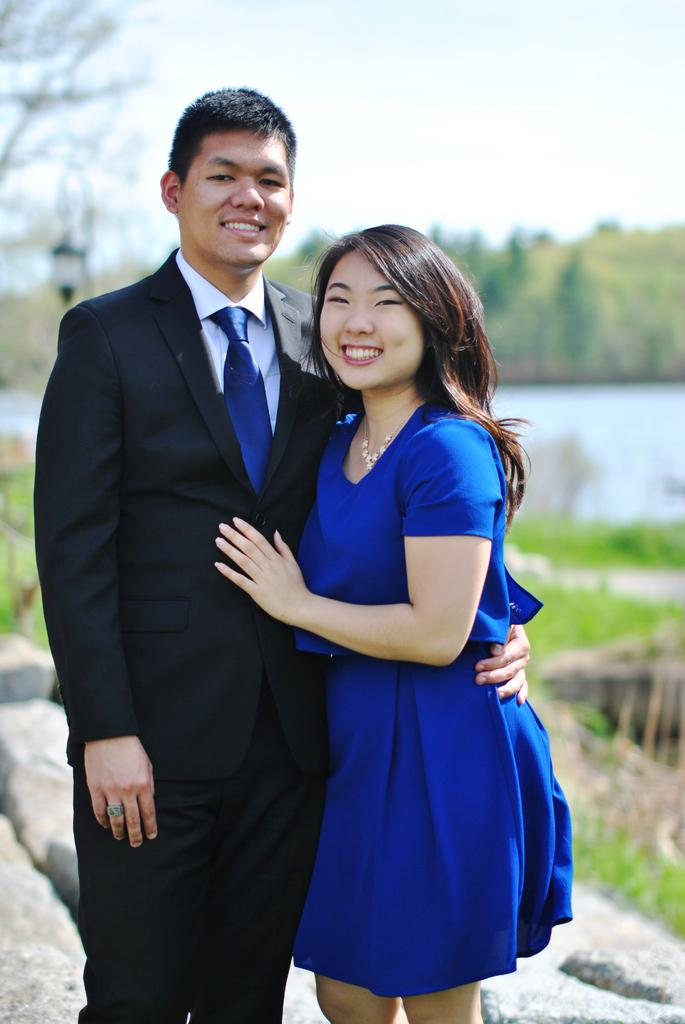How many people are in the image? There are two people in the image, a man and a woman. What are the man and the woman doing in the image? Both the man and the woman are standing and smiling. What type of natural elements can be seen in the image? There are rocks, water, and trees visible in the image. What is visible in the background of the image? The sky is visible in the background of the image. What type of bait is being used by the man in the image? There is no bait present in the image; the man is simply standing and smiling. How many visitors can be seen in the image? There is no visitor present in the image; only the man and the woman are visible. 